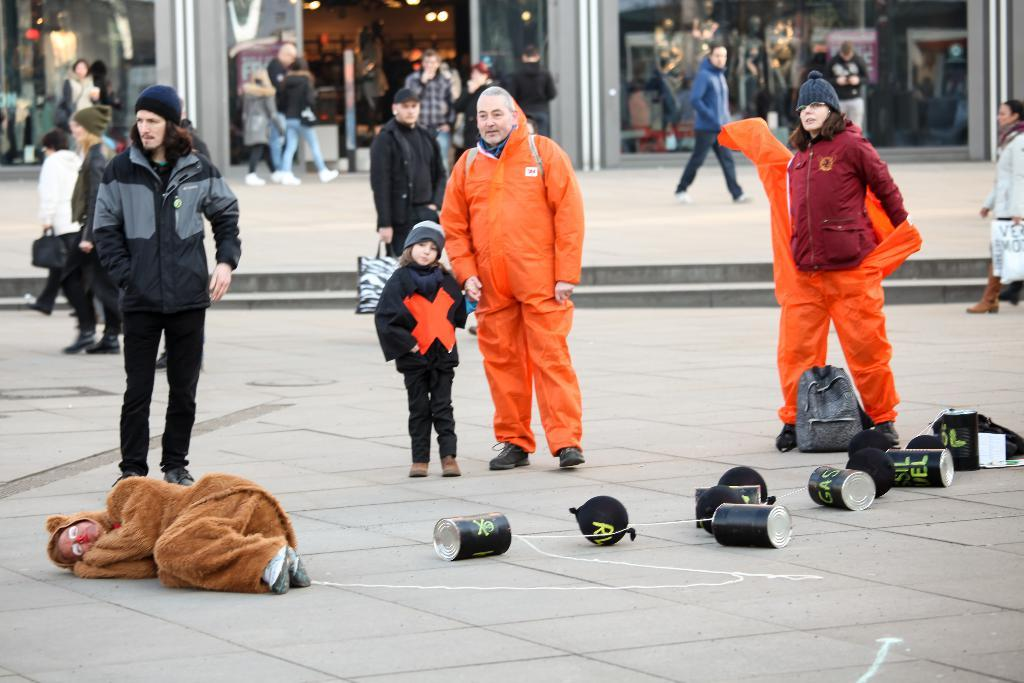How many people are in the image? There are three people in the image. What are the people wearing? The people are wearing orange color raincoats. What can be seen in the background of the image? There is a shop in the background of the image. Can you identify any specific feature of the image? There is a door visible in the image. What type of chicken can be seen in the vein of the orange raincoats? There is no chicken or vein present in the image; it features three people wearing orange color raincoats. 